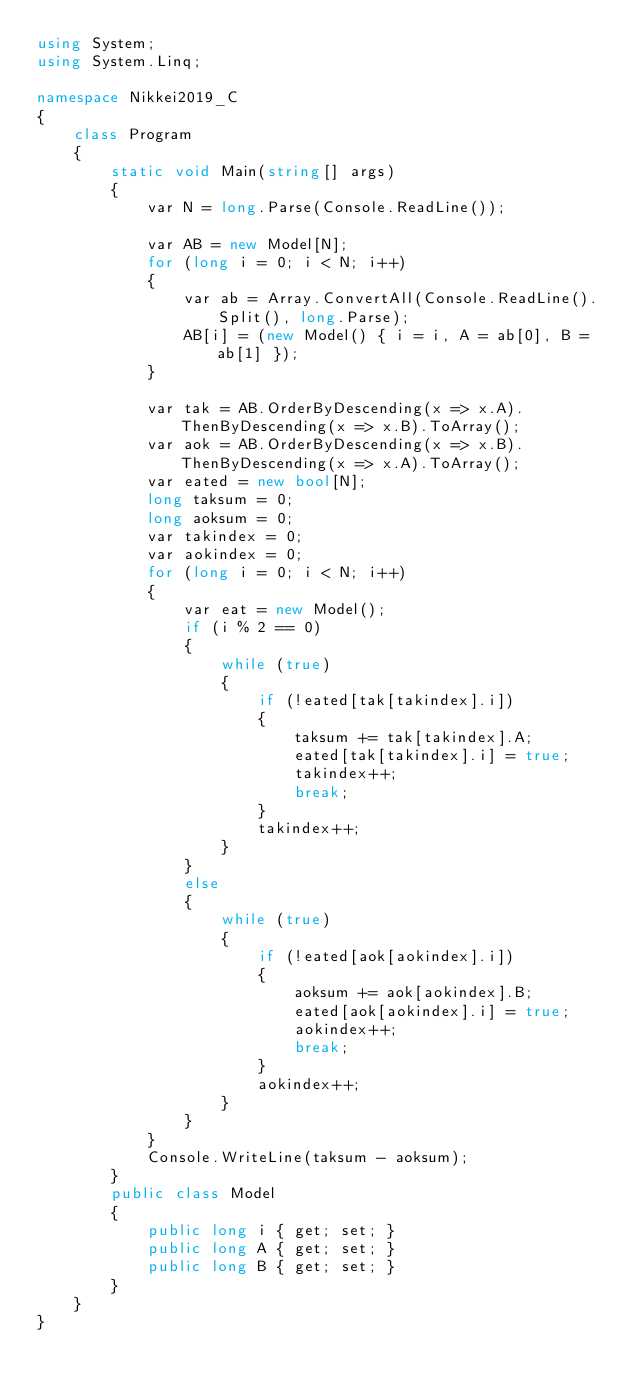Convert code to text. <code><loc_0><loc_0><loc_500><loc_500><_C#_>using System;
using System.Linq;

namespace Nikkei2019_C
{
    class Program
    {
        static void Main(string[] args)
        {
            var N = long.Parse(Console.ReadLine());

            var AB = new Model[N];
            for (long i = 0; i < N; i++)
            {
                var ab = Array.ConvertAll(Console.ReadLine().Split(), long.Parse);
                AB[i] = (new Model() { i = i, A = ab[0], B = ab[1] });
            }

            var tak = AB.OrderByDescending(x => x.A).ThenByDescending(x => x.B).ToArray();
            var aok = AB.OrderByDescending(x => x.B).ThenByDescending(x => x.A).ToArray();
            var eated = new bool[N];
            long taksum = 0;
            long aoksum = 0;
            var takindex = 0;
            var aokindex = 0;
            for (long i = 0; i < N; i++)
            {
                var eat = new Model();
                if (i % 2 == 0)
                {
                    while (true)
                    {
                        if (!eated[tak[takindex].i])
                        {
                            taksum += tak[takindex].A;
                            eated[tak[takindex].i] = true;
                            takindex++;
                            break;
                        }
                        takindex++;
                    }
                }
                else
                {
                    while (true)
                    {
                        if (!eated[aok[aokindex].i])
                        {
                            aoksum += aok[aokindex].B;
                            eated[aok[aokindex].i] = true;
                            aokindex++;
                            break;
                        }
                        aokindex++;
                    }
                }
            }
            Console.WriteLine(taksum - aoksum);
        }
        public class Model
        {
            public long i { get; set; }
            public long A { get; set; }
            public long B { get; set; }
        }
    }
}
</code> 